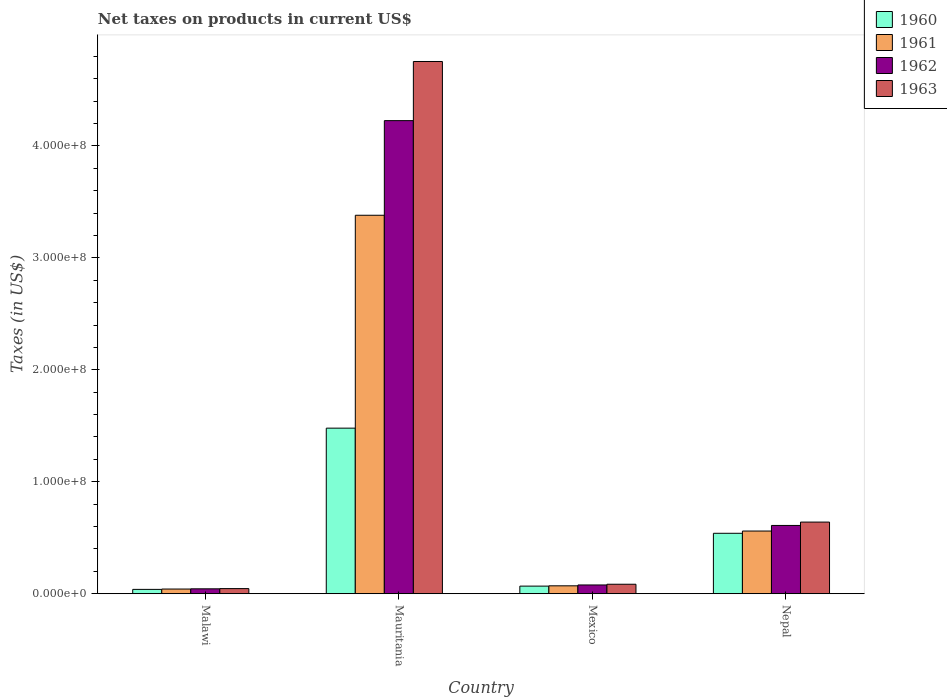How many groups of bars are there?
Your response must be concise. 4. How many bars are there on the 2nd tick from the left?
Ensure brevity in your answer.  4. What is the label of the 1st group of bars from the left?
Your answer should be compact. Malawi. What is the net taxes on products in 1962 in Mexico?
Offer a terse response. 7.85e+06. Across all countries, what is the maximum net taxes on products in 1960?
Provide a succinct answer. 1.48e+08. Across all countries, what is the minimum net taxes on products in 1963?
Give a very brief answer. 4.60e+06. In which country was the net taxes on products in 1961 maximum?
Keep it short and to the point. Mauritania. In which country was the net taxes on products in 1960 minimum?
Your response must be concise. Malawi. What is the total net taxes on products in 1963 in the graph?
Make the answer very short. 5.52e+08. What is the difference between the net taxes on products in 1962 in Mauritania and that in Nepal?
Offer a very short reply. 3.62e+08. What is the difference between the net taxes on products in 1962 in Malawi and the net taxes on products in 1961 in Nepal?
Provide a succinct answer. -5.16e+07. What is the average net taxes on products in 1960 per country?
Provide a succinct answer. 5.32e+07. What is the difference between the net taxes on products of/in 1962 and net taxes on products of/in 1960 in Mauritania?
Keep it short and to the point. 2.75e+08. In how many countries, is the net taxes on products in 1961 greater than 420000000 US$?
Offer a terse response. 0. What is the ratio of the net taxes on products in 1962 in Malawi to that in Mexico?
Make the answer very short. 0.56. Is the difference between the net taxes on products in 1962 in Malawi and Mauritania greater than the difference between the net taxes on products in 1960 in Malawi and Mauritania?
Ensure brevity in your answer.  No. What is the difference between the highest and the second highest net taxes on products in 1961?
Your response must be concise. 2.82e+08. What is the difference between the highest and the lowest net taxes on products in 1963?
Your answer should be very brief. 4.71e+08. Is the sum of the net taxes on products in 1963 in Mauritania and Nepal greater than the maximum net taxes on products in 1961 across all countries?
Give a very brief answer. Yes. Is it the case that in every country, the sum of the net taxes on products in 1961 and net taxes on products in 1960 is greater than the sum of net taxes on products in 1962 and net taxes on products in 1963?
Provide a succinct answer. No. What does the 3rd bar from the left in Mauritania represents?
Give a very brief answer. 1962. Is it the case that in every country, the sum of the net taxes on products in 1963 and net taxes on products in 1962 is greater than the net taxes on products in 1961?
Your response must be concise. Yes. Are all the bars in the graph horizontal?
Ensure brevity in your answer.  No. What is the difference between two consecutive major ticks on the Y-axis?
Ensure brevity in your answer.  1.00e+08. Where does the legend appear in the graph?
Your answer should be very brief. Top right. What is the title of the graph?
Your answer should be compact. Net taxes on products in current US$. What is the label or title of the X-axis?
Keep it short and to the point. Country. What is the label or title of the Y-axis?
Ensure brevity in your answer.  Taxes (in US$). What is the Taxes (in US$) of 1960 in Malawi?
Your answer should be very brief. 3.90e+06. What is the Taxes (in US$) of 1961 in Malawi?
Provide a succinct answer. 4.20e+06. What is the Taxes (in US$) of 1962 in Malawi?
Keep it short and to the point. 4.40e+06. What is the Taxes (in US$) in 1963 in Malawi?
Provide a short and direct response. 4.60e+06. What is the Taxes (in US$) in 1960 in Mauritania?
Ensure brevity in your answer.  1.48e+08. What is the Taxes (in US$) in 1961 in Mauritania?
Your answer should be very brief. 3.38e+08. What is the Taxes (in US$) of 1962 in Mauritania?
Your response must be concise. 4.23e+08. What is the Taxes (in US$) of 1963 in Mauritania?
Provide a short and direct response. 4.75e+08. What is the Taxes (in US$) of 1960 in Mexico?
Your answer should be compact. 6.81e+06. What is the Taxes (in US$) in 1961 in Mexico?
Ensure brevity in your answer.  7.08e+06. What is the Taxes (in US$) of 1962 in Mexico?
Offer a terse response. 7.85e+06. What is the Taxes (in US$) of 1963 in Mexico?
Make the answer very short. 8.49e+06. What is the Taxes (in US$) of 1960 in Nepal?
Provide a short and direct response. 5.40e+07. What is the Taxes (in US$) of 1961 in Nepal?
Provide a short and direct response. 5.60e+07. What is the Taxes (in US$) of 1962 in Nepal?
Provide a short and direct response. 6.10e+07. What is the Taxes (in US$) in 1963 in Nepal?
Your response must be concise. 6.40e+07. Across all countries, what is the maximum Taxes (in US$) in 1960?
Provide a succinct answer. 1.48e+08. Across all countries, what is the maximum Taxes (in US$) of 1961?
Offer a terse response. 3.38e+08. Across all countries, what is the maximum Taxes (in US$) of 1962?
Ensure brevity in your answer.  4.23e+08. Across all countries, what is the maximum Taxes (in US$) of 1963?
Ensure brevity in your answer.  4.75e+08. Across all countries, what is the minimum Taxes (in US$) of 1960?
Your response must be concise. 3.90e+06. Across all countries, what is the minimum Taxes (in US$) of 1961?
Provide a short and direct response. 4.20e+06. Across all countries, what is the minimum Taxes (in US$) in 1962?
Your answer should be compact. 4.40e+06. Across all countries, what is the minimum Taxes (in US$) of 1963?
Your answer should be compact. 4.60e+06. What is the total Taxes (in US$) of 1960 in the graph?
Provide a succinct answer. 2.13e+08. What is the total Taxes (in US$) of 1961 in the graph?
Provide a succinct answer. 4.05e+08. What is the total Taxes (in US$) in 1962 in the graph?
Keep it short and to the point. 4.96e+08. What is the total Taxes (in US$) of 1963 in the graph?
Your answer should be very brief. 5.52e+08. What is the difference between the Taxes (in US$) of 1960 in Malawi and that in Mauritania?
Your answer should be very brief. -1.44e+08. What is the difference between the Taxes (in US$) in 1961 in Malawi and that in Mauritania?
Provide a short and direct response. -3.34e+08. What is the difference between the Taxes (in US$) of 1962 in Malawi and that in Mauritania?
Your answer should be very brief. -4.18e+08. What is the difference between the Taxes (in US$) of 1963 in Malawi and that in Mauritania?
Provide a short and direct response. -4.71e+08. What is the difference between the Taxes (in US$) in 1960 in Malawi and that in Mexico?
Make the answer very short. -2.91e+06. What is the difference between the Taxes (in US$) in 1961 in Malawi and that in Mexico?
Give a very brief answer. -2.88e+06. What is the difference between the Taxes (in US$) of 1962 in Malawi and that in Mexico?
Keep it short and to the point. -3.45e+06. What is the difference between the Taxes (in US$) of 1963 in Malawi and that in Mexico?
Ensure brevity in your answer.  -3.89e+06. What is the difference between the Taxes (in US$) of 1960 in Malawi and that in Nepal?
Your answer should be compact. -5.01e+07. What is the difference between the Taxes (in US$) in 1961 in Malawi and that in Nepal?
Your response must be concise. -5.18e+07. What is the difference between the Taxes (in US$) in 1962 in Malawi and that in Nepal?
Offer a very short reply. -5.66e+07. What is the difference between the Taxes (in US$) of 1963 in Malawi and that in Nepal?
Make the answer very short. -5.94e+07. What is the difference between the Taxes (in US$) of 1960 in Mauritania and that in Mexico?
Your answer should be compact. 1.41e+08. What is the difference between the Taxes (in US$) in 1961 in Mauritania and that in Mexico?
Provide a short and direct response. 3.31e+08. What is the difference between the Taxes (in US$) in 1962 in Mauritania and that in Mexico?
Give a very brief answer. 4.15e+08. What is the difference between the Taxes (in US$) in 1963 in Mauritania and that in Mexico?
Offer a very short reply. 4.67e+08. What is the difference between the Taxes (in US$) in 1960 in Mauritania and that in Nepal?
Keep it short and to the point. 9.39e+07. What is the difference between the Taxes (in US$) of 1961 in Mauritania and that in Nepal?
Offer a terse response. 2.82e+08. What is the difference between the Taxes (in US$) of 1962 in Mauritania and that in Nepal?
Provide a short and direct response. 3.62e+08. What is the difference between the Taxes (in US$) of 1963 in Mauritania and that in Nepal?
Your answer should be compact. 4.11e+08. What is the difference between the Taxes (in US$) in 1960 in Mexico and that in Nepal?
Your answer should be compact. -4.72e+07. What is the difference between the Taxes (in US$) in 1961 in Mexico and that in Nepal?
Give a very brief answer. -4.89e+07. What is the difference between the Taxes (in US$) of 1962 in Mexico and that in Nepal?
Give a very brief answer. -5.32e+07. What is the difference between the Taxes (in US$) in 1963 in Mexico and that in Nepal?
Your answer should be very brief. -5.55e+07. What is the difference between the Taxes (in US$) in 1960 in Malawi and the Taxes (in US$) in 1961 in Mauritania?
Your answer should be very brief. -3.34e+08. What is the difference between the Taxes (in US$) of 1960 in Malawi and the Taxes (in US$) of 1962 in Mauritania?
Your response must be concise. -4.19e+08. What is the difference between the Taxes (in US$) of 1960 in Malawi and the Taxes (in US$) of 1963 in Mauritania?
Your answer should be compact. -4.71e+08. What is the difference between the Taxes (in US$) in 1961 in Malawi and the Taxes (in US$) in 1962 in Mauritania?
Make the answer very short. -4.18e+08. What is the difference between the Taxes (in US$) of 1961 in Malawi and the Taxes (in US$) of 1963 in Mauritania?
Your answer should be very brief. -4.71e+08. What is the difference between the Taxes (in US$) of 1962 in Malawi and the Taxes (in US$) of 1963 in Mauritania?
Keep it short and to the point. -4.71e+08. What is the difference between the Taxes (in US$) in 1960 in Malawi and the Taxes (in US$) in 1961 in Mexico?
Your answer should be compact. -3.18e+06. What is the difference between the Taxes (in US$) of 1960 in Malawi and the Taxes (in US$) of 1962 in Mexico?
Provide a succinct answer. -3.95e+06. What is the difference between the Taxes (in US$) in 1960 in Malawi and the Taxes (in US$) in 1963 in Mexico?
Offer a very short reply. -4.59e+06. What is the difference between the Taxes (in US$) of 1961 in Malawi and the Taxes (in US$) of 1962 in Mexico?
Make the answer very short. -3.65e+06. What is the difference between the Taxes (in US$) in 1961 in Malawi and the Taxes (in US$) in 1963 in Mexico?
Offer a terse response. -4.29e+06. What is the difference between the Taxes (in US$) in 1962 in Malawi and the Taxes (in US$) in 1963 in Mexico?
Give a very brief answer. -4.09e+06. What is the difference between the Taxes (in US$) in 1960 in Malawi and the Taxes (in US$) in 1961 in Nepal?
Offer a very short reply. -5.21e+07. What is the difference between the Taxes (in US$) in 1960 in Malawi and the Taxes (in US$) in 1962 in Nepal?
Your response must be concise. -5.71e+07. What is the difference between the Taxes (in US$) in 1960 in Malawi and the Taxes (in US$) in 1963 in Nepal?
Give a very brief answer. -6.01e+07. What is the difference between the Taxes (in US$) in 1961 in Malawi and the Taxes (in US$) in 1962 in Nepal?
Offer a terse response. -5.68e+07. What is the difference between the Taxes (in US$) of 1961 in Malawi and the Taxes (in US$) of 1963 in Nepal?
Your answer should be very brief. -5.98e+07. What is the difference between the Taxes (in US$) of 1962 in Malawi and the Taxes (in US$) of 1963 in Nepal?
Your response must be concise. -5.96e+07. What is the difference between the Taxes (in US$) of 1960 in Mauritania and the Taxes (in US$) of 1961 in Mexico?
Provide a short and direct response. 1.41e+08. What is the difference between the Taxes (in US$) in 1960 in Mauritania and the Taxes (in US$) in 1962 in Mexico?
Keep it short and to the point. 1.40e+08. What is the difference between the Taxes (in US$) in 1960 in Mauritania and the Taxes (in US$) in 1963 in Mexico?
Provide a short and direct response. 1.39e+08. What is the difference between the Taxes (in US$) in 1961 in Mauritania and the Taxes (in US$) in 1962 in Mexico?
Offer a very short reply. 3.30e+08. What is the difference between the Taxes (in US$) in 1961 in Mauritania and the Taxes (in US$) in 1963 in Mexico?
Your answer should be compact. 3.30e+08. What is the difference between the Taxes (in US$) of 1962 in Mauritania and the Taxes (in US$) of 1963 in Mexico?
Make the answer very short. 4.14e+08. What is the difference between the Taxes (in US$) in 1960 in Mauritania and the Taxes (in US$) in 1961 in Nepal?
Offer a very short reply. 9.19e+07. What is the difference between the Taxes (in US$) in 1960 in Mauritania and the Taxes (in US$) in 1962 in Nepal?
Provide a succinct answer. 8.69e+07. What is the difference between the Taxes (in US$) of 1960 in Mauritania and the Taxes (in US$) of 1963 in Nepal?
Offer a very short reply. 8.39e+07. What is the difference between the Taxes (in US$) of 1961 in Mauritania and the Taxes (in US$) of 1962 in Nepal?
Your answer should be very brief. 2.77e+08. What is the difference between the Taxes (in US$) in 1961 in Mauritania and the Taxes (in US$) in 1963 in Nepal?
Make the answer very short. 2.74e+08. What is the difference between the Taxes (in US$) of 1962 in Mauritania and the Taxes (in US$) of 1963 in Nepal?
Keep it short and to the point. 3.59e+08. What is the difference between the Taxes (in US$) in 1960 in Mexico and the Taxes (in US$) in 1961 in Nepal?
Ensure brevity in your answer.  -4.92e+07. What is the difference between the Taxes (in US$) of 1960 in Mexico and the Taxes (in US$) of 1962 in Nepal?
Your answer should be compact. -5.42e+07. What is the difference between the Taxes (in US$) of 1960 in Mexico and the Taxes (in US$) of 1963 in Nepal?
Provide a succinct answer. -5.72e+07. What is the difference between the Taxes (in US$) of 1961 in Mexico and the Taxes (in US$) of 1962 in Nepal?
Your response must be concise. -5.39e+07. What is the difference between the Taxes (in US$) in 1961 in Mexico and the Taxes (in US$) in 1963 in Nepal?
Make the answer very short. -5.69e+07. What is the difference between the Taxes (in US$) of 1962 in Mexico and the Taxes (in US$) of 1963 in Nepal?
Your response must be concise. -5.62e+07. What is the average Taxes (in US$) of 1960 per country?
Your answer should be very brief. 5.32e+07. What is the average Taxes (in US$) of 1961 per country?
Your answer should be very brief. 1.01e+08. What is the average Taxes (in US$) in 1962 per country?
Offer a terse response. 1.24e+08. What is the average Taxes (in US$) of 1963 per country?
Offer a very short reply. 1.38e+08. What is the difference between the Taxes (in US$) of 1960 and Taxes (in US$) of 1961 in Malawi?
Your answer should be very brief. -3.00e+05. What is the difference between the Taxes (in US$) in 1960 and Taxes (in US$) in 1962 in Malawi?
Keep it short and to the point. -5.00e+05. What is the difference between the Taxes (in US$) of 1960 and Taxes (in US$) of 1963 in Malawi?
Provide a short and direct response. -7.00e+05. What is the difference between the Taxes (in US$) of 1961 and Taxes (in US$) of 1962 in Malawi?
Offer a very short reply. -2.00e+05. What is the difference between the Taxes (in US$) of 1961 and Taxes (in US$) of 1963 in Malawi?
Offer a very short reply. -4.00e+05. What is the difference between the Taxes (in US$) in 1960 and Taxes (in US$) in 1961 in Mauritania?
Keep it short and to the point. -1.90e+08. What is the difference between the Taxes (in US$) in 1960 and Taxes (in US$) in 1962 in Mauritania?
Keep it short and to the point. -2.75e+08. What is the difference between the Taxes (in US$) in 1960 and Taxes (in US$) in 1963 in Mauritania?
Offer a very short reply. -3.27e+08. What is the difference between the Taxes (in US$) of 1961 and Taxes (in US$) of 1962 in Mauritania?
Ensure brevity in your answer.  -8.45e+07. What is the difference between the Taxes (in US$) of 1961 and Taxes (in US$) of 1963 in Mauritania?
Your answer should be very brief. -1.37e+08. What is the difference between the Taxes (in US$) of 1962 and Taxes (in US$) of 1963 in Mauritania?
Provide a short and direct response. -5.28e+07. What is the difference between the Taxes (in US$) of 1960 and Taxes (in US$) of 1961 in Mexico?
Your answer should be compact. -2.73e+05. What is the difference between the Taxes (in US$) of 1960 and Taxes (in US$) of 1962 in Mexico?
Ensure brevity in your answer.  -1.04e+06. What is the difference between the Taxes (in US$) in 1960 and Taxes (in US$) in 1963 in Mexico?
Offer a terse response. -1.69e+06. What is the difference between the Taxes (in US$) of 1961 and Taxes (in US$) of 1962 in Mexico?
Keep it short and to the point. -7.69e+05. What is the difference between the Taxes (in US$) in 1961 and Taxes (in US$) in 1963 in Mexico?
Your answer should be compact. -1.41e+06. What is the difference between the Taxes (in US$) in 1962 and Taxes (in US$) in 1963 in Mexico?
Provide a succinct answer. -6.43e+05. What is the difference between the Taxes (in US$) in 1960 and Taxes (in US$) in 1961 in Nepal?
Your response must be concise. -2.00e+06. What is the difference between the Taxes (in US$) in 1960 and Taxes (in US$) in 1962 in Nepal?
Provide a short and direct response. -7.00e+06. What is the difference between the Taxes (in US$) of 1960 and Taxes (in US$) of 1963 in Nepal?
Ensure brevity in your answer.  -1.00e+07. What is the difference between the Taxes (in US$) of 1961 and Taxes (in US$) of 1962 in Nepal?
Make the answer very short. -5.00e+06. What is the difference between the Taxes (in US$) in 1961 and Taxes (in US$) in 1963 in Nepal?
Your response must be concise. -8.00e+06. What is the difference between the Taxes (in US$) in 1962 and Taxes (in US$) in 1963 in Nepal?
Provide a short and direct response. -3.00e+06. What is the ratio of the Taxes (in US$) of 1960 in Malawi to that in Mauritania?
Your response must be concise. 0.03. What is the ratio of the Taxes (in US$) of 1961 in Malawi to that in Mauritania?
Offer a terse response. 0.01. What is the ratio of the Taxes (in US$) in 1962 in Malawi to that in Mauritania?
Keep it short and to the point. 0.01. What is the ratio of the Taxes (in US$) in 1963 in Malawi to that in Mauritania?
Keep it short and to the point. 0.01. What is the ratio of the Taxes (in US$) in 1960 in Malawi to that in Mexico?
Your answer should be very brief. 0.57. What is the ratio of the Taxes (in US$) of 1961 in Malawi to that in Mexico?
Your answer should be compact. 0.59. What is the ratio of the Taxes (in US$) of 1962 in Malawi to that in Mexico?
Your response must be concise. 0.56. What is the ratio of the Taxes (in US$) in 1963 in Malawi to that in Mexico?
Keep it short and to the point. 0.54. What is the ratio of the Taxes (in US$) in 1960 in Malawi to that in Nepal?
Offer a terse response. 0.07. What is the ratio of the Taxes (in US$) in 1961 in Malawi to that in Nepal?
Your response must be concise. 0.07. What is the ratio of the Taxes (in US$) of 1962 in Malawi to that in Nepal?
Your answer should be very brief. 0.07. What is the ratio of the Taxes (in US$) in 1963 in Malawi to that in Nepal?
Your response must be concise. 0.07. What is the ratio of the Taxes (in US$) of 1960 in Mauritania to that in Mexico?
Offer a terse response. 21.73. What is the ratio of the Taxes (in US$) in 1961 in Mauritania to that in Mexico?
Offer a terse response. 47.75. What is the ratio of the Taxes (in US$) in 1962 in Mauritania to that in Mexico?
Your answer should be compact. 53.84. What is the ratio of the Taxes (in US$) in 1963 in Mauritania to that in Mexico?
Make the answer very short. 55.98. What is the ratio of the Taxes (in US$) in 1960 in Mauritania to that in Nepal?
Offer a terse response. 2.74. What is the ratio of the Taxes (in US$) of 1961 in Mauritania to that in Nepal?
Make the answer very short. 6.04. What is the ratio of the Taxes (in US$) of 1962 in Mauritania to that in Nepal?
Give a very brief answer. 6.93. What is the ratio of the Taxes (in US$) of 1963 in Mauritania to that in Nepal?
Your response must be concise. 7.43. What is the ratio of the Taxes (in US$) of 1960 in Mexico to that in Nepal?
Offer a very short reply. 0.13. What is the ratio of the Taxes (in US$) in 1961 in Mexico to that in Nepal?
Offer a very short reply. 0.13. What is the ratio of the Taxes (in US$) in 1962 in Mexico to that in Nepal?
Keep it short and to the point. 0.13. What is the ratio of the Taxes (in US$) of 1963 in Mexico to that in Nepal?
Your answer should be very brief. 0.13. What is the difference between the highest and the second highest Taxes (in US$) of 1960?
Provide a short and direct response. 9.39e+07. What is the difference between the highest and the second highest Taxes (in US$) in 1961?
Keep it short and to the point. 2.82e+08. What is the difference between the highest and the second highest Taxes (in US$) in 1962?
Offer a very short reply. 3.62e+08. What is the difference between the highest and the second highest Taxes (in US$) in 1963?
Offer a very short reply. 4.11e+08. What is the difference between the highest and the lowest Taxes (in US$) in 1960?
Offer a very short reply. 1.44e+08. What is the difference between the highest and the lowest Taxes (in US$) of 1961?
Make the answer very short. 3.34e+08. What is the difference between the highest and the lowest Taxes (in US$) of 1962?
Make the answer very short. 4.18e+08. What is the difference between the highest and the lowest Taxes (in US$) in 1963?
Keep it short and to the point. 4.71e+08. 